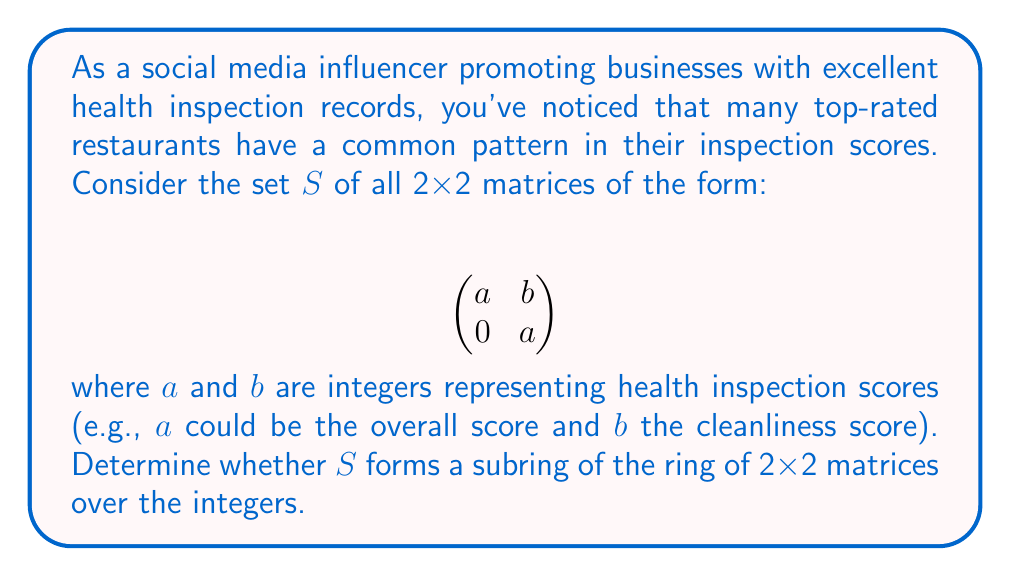Can you solve this math problem? To determine if $S$ is a subring, we need to check three conditions:

1. Closure under addition
2. Closure under multiplication
3. Closure under subtraction (or additive inverse)

Let's check each condition:

1. Closure under addition:
   Let $A = \begin{pmatrix} a & b \\ 0 & a \end{pmatrix}$ and $B = \begin{pmatrix} c & d \\ 0 & c \end{pmatrix}$ be two matrices in $S$.
   
   $A + B = \begin{pmatrix} a & b \\ 0 & a \end{pmatrix} + \begin{pmatrix} c & d \\ 0 & c \end{pmatrix} = \begin{pmatrix} a+c & b+d \\ 0 & a+c \end{pmatrix}$
   
   The result is in $S$ since $a+c$ and $b+d$ are integers.

2. Closure under multiplication:
   $A \cdot B = \begin{pmatrix} a & b \\ 0 & a \end{pmatrix} \cdot \begin{pmatrix} c & d \\ 0 & c \end{pmatrix} = \begin{pmatrix} ac & ad+bc \\ 0 & ac \end{pmatrix}$
   
   The result is in $S$ since $ac$ and $ad+bc$ are integers.

3. Closure under subtraction:
   $A - B = \begin{pmatrix} a & b \\ 0 & a \end{pmatrix} - \begin{pmatrix} c & d \\ 0 & c \end{pmatrix} = \begin{pmatrix} a-c & b-d \\ 0 & a-c \end{pmatrix}$
   
   The result is in $S$ since $a-c$ and $b-d$ are integers.

Additionally, $S$ contains the zero matrix $\begin{pmatrix} 0 & 0 \\ 0 & 0 \end{pmatrix}$, which serves as the additive identity.

Since all three conditions are satisfied and $S$ contains the additive identity, $S$ forms a subring of the ring of 2x2 matrices over the integers.
Answer: Yes, $S$ forms a subring of the ring of 2x2 matrices over the integers. 